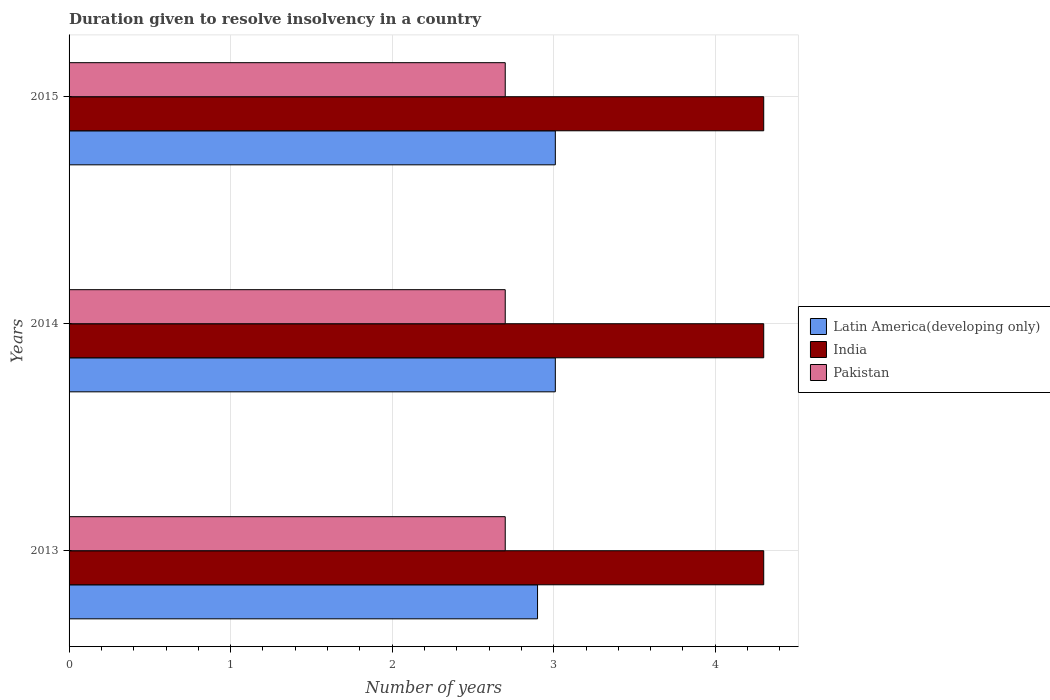How many different coloured bars are there?
Keep it short and to the point. 3. How many groups of bars are there?
Offer a terse response. 3. Are the number of bars on each tick of the Y-axis equal?
Your answer should be compact. Yes. How many bars are there on the 2nd tick from the bottom?
Provide a succinct answer. 3. What is the label of the 1st group of bars from the top?
Keep it short and to the point. 2015. Across all years, what is the maximum duration given to resolve insolvency in in Pakistan?
Offer a very short reply. 2.7. What is the total duration given to resolve insolvency in in Latin America(developing only) in the graph?
Provide a succinct answer. 8.92. What is the difference between the duration given to resolve insolvency in in India in 2014 and the duration given to resolve insolvency in in Latin America(developing only) in 2013?
Your answer should be compact. 1.4. In the year 2013, what is the difference between the duration given to resolve insolvency in in India and duration given to resolve insolvency in in Latin America(developing only)?
Give a very brief answer. 1.4. What is the difference between the highest and the lowest duration given to resolve insolvency in in Latin America(developing only)?
Your response must be concise. 0.11. In how many years, is the duration given to resolve insolvency in in Latin America(developing only) greater than the average duration given to resolve insolvency in in Latin America(developing only) taken over all years?
Ensure brevity in your answer.  2. Is the sum of the duration given to resolve insolvency in in Latin America(developing only) in 2013 and 2015 greater than the maximum duration given to resolve insolvency in in Pakistan across all years?
Provide a short and direct response. Yes. What does the 2nd bar from the top in 2013 represents?
Provide a succinct answer. India. What does the 3rd bar from the bottom in 2013 represents?
Your response must be concise. Pakistan. Is it the case that in every year, the sum of the duration given to resolve insolvency in in Pakistan and duration given to resolve insolvency in in India is greater than the duration given to resolve insolvency in in Latin America(developing only)?
Provide a succinct answer. Yes. What is the difference between two consecutive major ticks on the X-axis?
Provide a short and direct response. 1. Does the graph contain grids?
Your answer should be compact. Yes. How many legend labels are there?
Your answer should be compact. 3. What is the title of the graph?
Offer a very short reply. Duration given to resolve insolvency in a country. Does "China" appear as one of the legend labels in the graph?
Make the answer very short. No. What is the label or title of the X-axis?
Keep it short and to the point. Number of years. What is the Number of years of Latin America(developing only) in 2013?
Make the answer very short. 2.9. What is the Number of years of Latin America(developing only) in 2014?
Keep it short and to the point. 3.01. What is the Number of years of India in 2014?
Keep it short and to the point. 4.3. What is the Number of years in Latin America(developing only) in 2015?
Provide a short and direct response. 3.01. What is the Number of years of Pakistan in 2015?
Offer a very short reply. 2.7. Across all years, what is the maximum Number of years in Latin America(developing only)?
Offer a very short reply. 3.01. Across all years, what is the minimum Number of years of Latin America(developing only)?
Provide a succinct answer. 2.9. Across all years, what is the minimum Number of years in India?
Offer a terse response. 4.3. Across all years, what is the minimum Number of years in Pakistan?
Offer a terse response. 2.7. What is the total Number of years in Latin America(developing only) in the graph?
Offer a terse response. 8.92. What is the total Number of years of India in the graph?
Provide a succinct answer. 12.9. What is the difference between the Number of years in Latin America(developing only) in 2013 and that in 2014?
Make the answer very short. -0.11. What is the difference between the Number of years of India in 2013 and that in 2014?
Your answer should be very brief. 0. What is the difference between the Number of years in Latin America(developing only) in 2013 and that in 2015?
Provide a short and direct response. -0.11. What is the difference between the Number of years in Latin America(developing only) in 2014 and that in 2015?
Keep it short and to the point. 0. What is the difference between the Number of years in Pakistan in 2014 and that in 2015?
Offer a very short reply. 0. What is the difference between the Number of years in Latin America(developing only) in 2013 and the Number of years in India in 2014?
Your response must be concise. -1.4. What is the difference between the Number of years of India in 2013 and the Number of years of Pakistan in 2014?
Offer a very short reply. 1.6. What is the difference between the Number of years of Latin America(developing only) in 2013 and the Number of years of Pakistan in 2015?
Keep it short and to the point. 0.2. What is the difference between the Number of years of Latin America(developing only) in 2014 and the Number of years of India in 2015?
Provide a short and direct response. -1.29. What is the difference between the Number of years of Latin America(developing only) in 2014 and the Number of years of Pakistan in 2015?
Give a very brief answer. 0.31. What is the average Number of years of Latin America(developing only) per year?
Your answer should be compact. 2.97. What is the average Number of years in India per year?
Your response must be concise. 4.3. In the year 2013, what is the difference between the Number of years of Latin America(developing only) and Number of years of India?
Offer a terse response. -1.4. In the year 2013, what is the difference between the Number of years in India and Number of years in Pakistan?
Provide a succinct answer. 1.6. In the year 2014, what is the difference between the Number of years of Latin America(developing only) and Number of years of India?
Keep it short and to the point. -1.29. In the year 2014, what is the difference between the Number of years in Latin America(developing only) and Number of years in Pakistan?
Provide a short and direct response. 0.31. In the year 2015, what is the difference between the Number of years in Latin America(developing only) and Number of years in India?
Provide a short and direct response. -1.29. In the year 2015, what is the difference between the Number of years in Latin America(developing only) and Number of years in Pakistan?
Make the answer very short. 0.31. In the year 2015, what is the difference between the Number of years of India and Number of years of Pakistan?
Make the answer very short. 1.6. What is the ratio of the Number of years in Latin America(developing only) in 2013 to that in 2014?
Your response must be concise. 0.96. What is the ratio of the Number of years in India in 2013 to that in 2014?
Offer a terse response. 1. What is the ratio of the Number of years of Pakistan in 2013 to that in 2014?
Your response must be concise. 1. What is the ratio of the Number of years in Latin America(developing only) in 2013 to that in 2015?
Your response must be concise. 0.96. What is the ratio of the Number of years in India in 2013 to that in 2015?
Keep it short and to the point. 1. What is the ratio of the Number of years in Pakistan in 2013 to that in 2015?
Your response must be concise. 1. What is the ratio of the Number of years in India in 2014 to that in 2015?
Give a very brief answer. 1. What is the ratio of the Number of years in Pakistan in 2014 to that in 2015?
Ensure brevity in your answer.  1. What is the difference between the highest and the second highest Number of years of Latin America(developing only)?
Offer a terse response. 0. What is the difference between the highest and the second highest Number of years of India?
Your answer should be compact. 0. What is the difference between the highest and the second highest Number of years in Pakistan?
Your answer should be very brief. 0. What is the difference between the highest and the lowest Number of years of Latin America(developing only)?
Ensure brevity in your answer.  0.11. What is the difference between the highest and the lowest Number of years in India?
Your answer should be compact. 0. What is the difference between the highest and the lowest Number of years of Pakistan?
Your answer should be very brief. 0. 